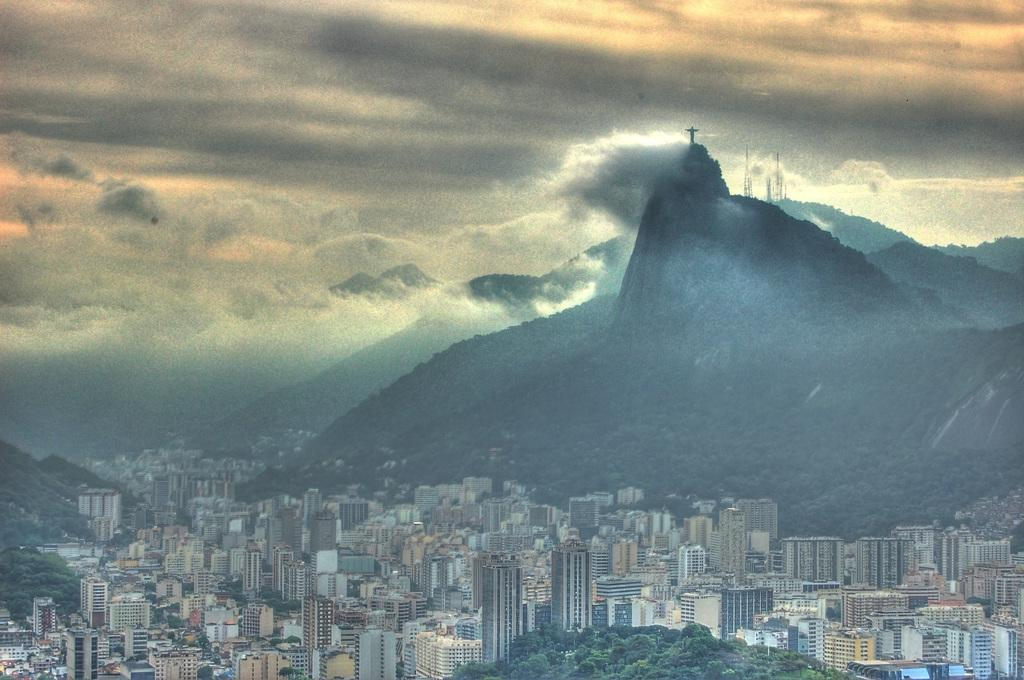What type of view is shown in the image? The image is an aerial view. What can be seen in the image from this perspective? There are many buildings, trees, and hills visible in the image. What is visible in the background of the image? The sky is visible in the image. What type of headphones are being used by the trees in the image? There are no headphones or trees using them in the image. What type of acoustics can be heard in the image? There is no sound or acoustics present in the image, as it is a still photograph. 